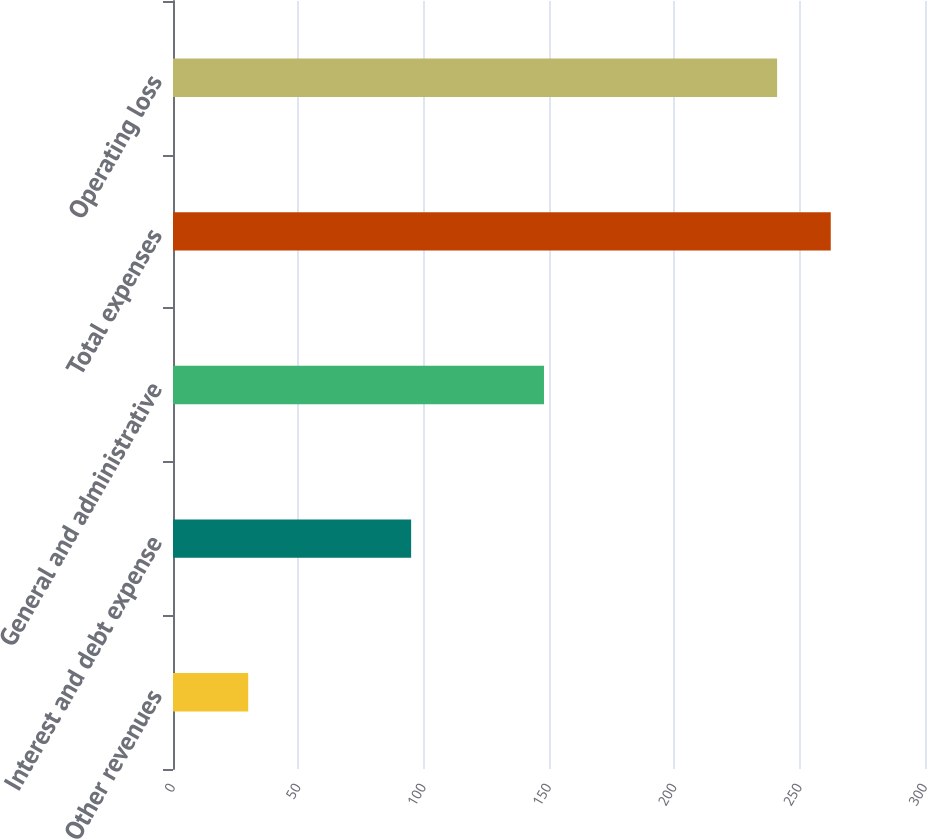Convert chart. <chart><loc_0><loc_0><loc_500><loc_500><bar_chart><fcel>Other revenues<fcel>Interest and debt expense<fcel>General and administrative<fcel>Total expenses<fcel>Operating loss<nl><fcel>30<fcel>95<fcel>148<fcel>262.4<fcel>241<nl></chart> 